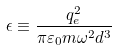Convert formula to latex. <formula><loc_0><loc_0><loc_500><loc_500>\epsilon \equiv \frac { q _ { e } ^ { 2 } } { \pi \varepsilon _ { 0 } m \omega ^ { 2 } d ^ { 3 } }</formula> 